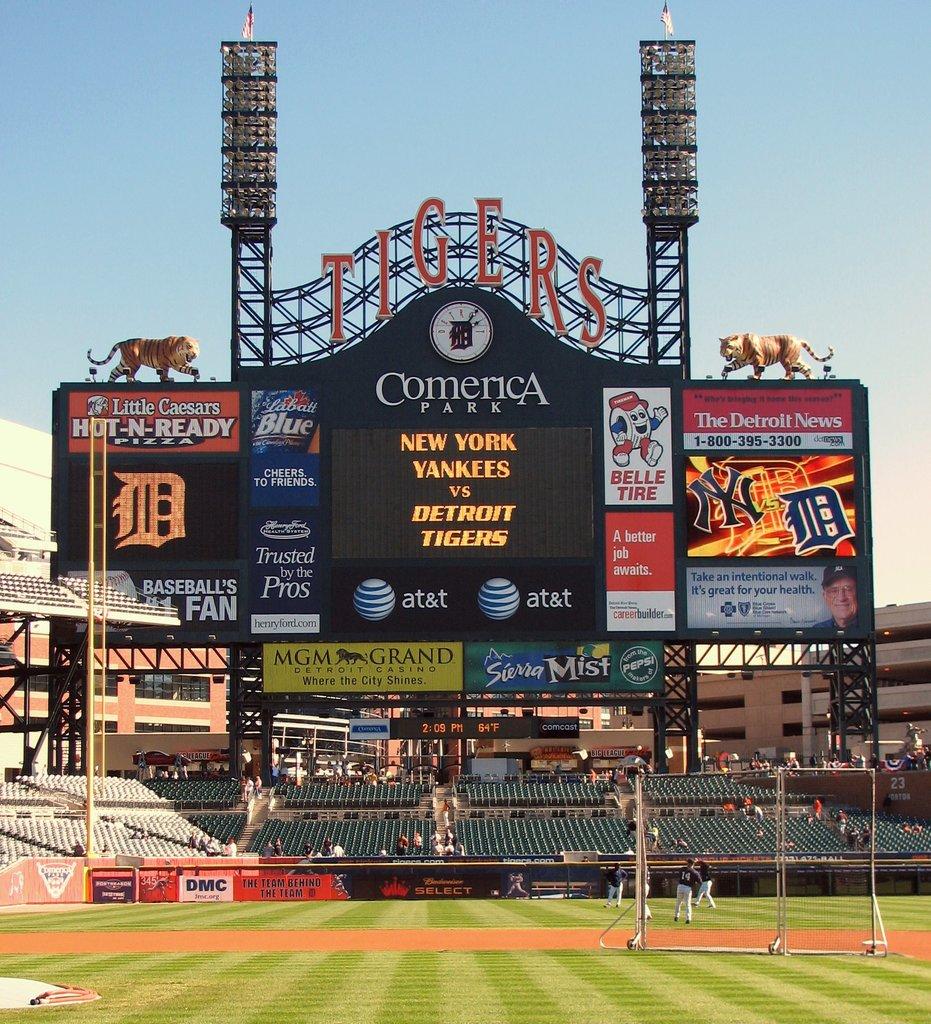What ballpark is listed here?
Give a very brief answer. Comerica. 